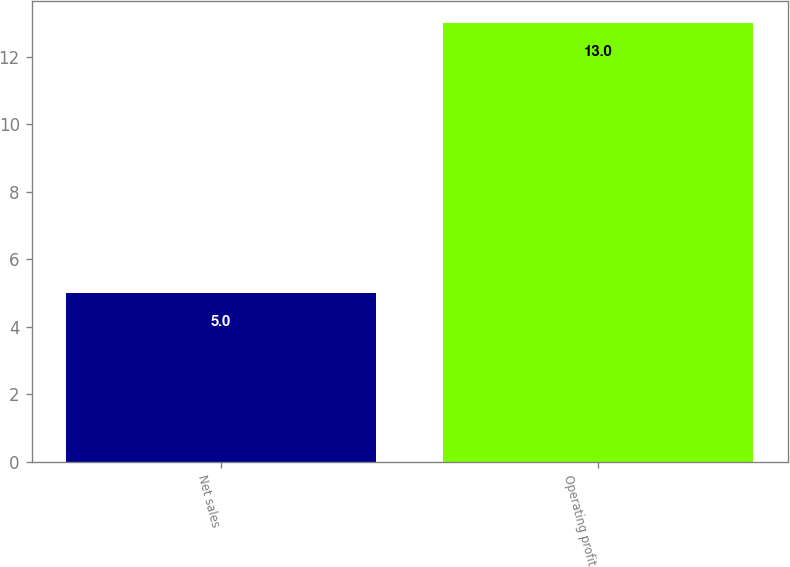<chart> <loc_0><loc_0><loc_500><loc_500><bar_chart><fcel>Net sales<fcel>Operating profit<nl><fcel>5<fcel>13<nl></chart> 